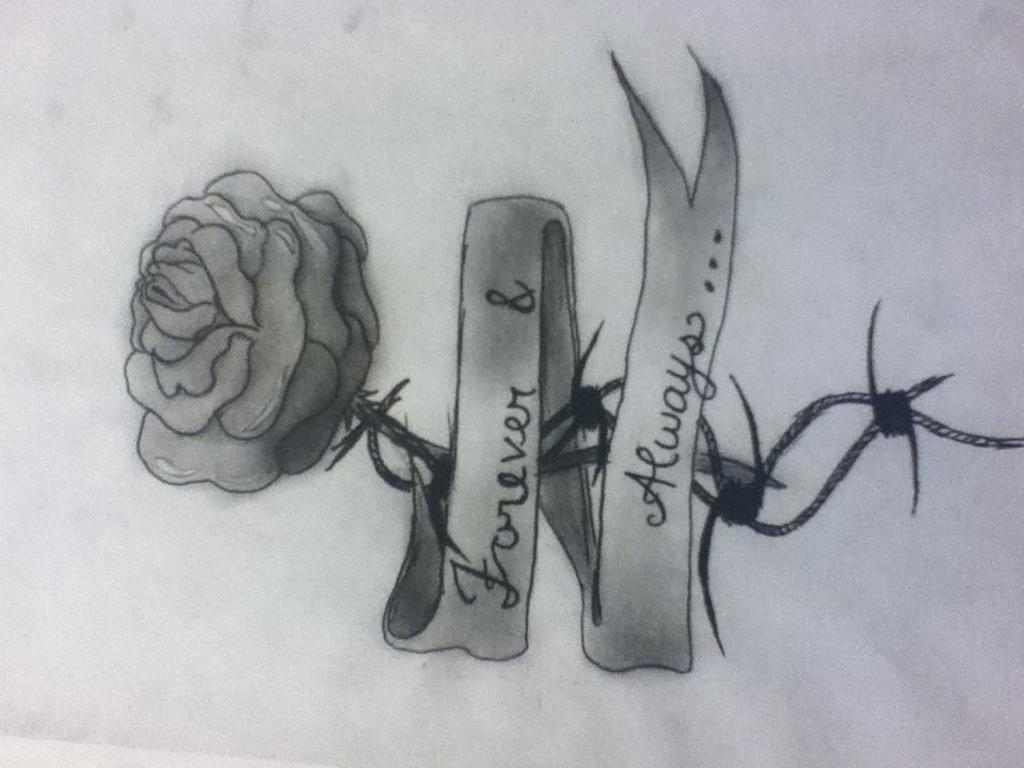What is depicted in the drawing in the image? There is a drawing of a rose flower in the image. What part of the rose flower is visible in the drawing? The rose flower has a stem in the drawing. Are there any additional features on the stem? Yes, the stem has thorns in the drawing. What is wrapped around the rose flower in the drawing? There is a ribbon around the rose flower in the drawing. Is there any text or personalization on the ribbon? Yes, the ribbon has a name on it. Where is the cushion placed in the image? There is no cushion present in the image; it only features a drawing of a rose flower with a ribbon and a name. 